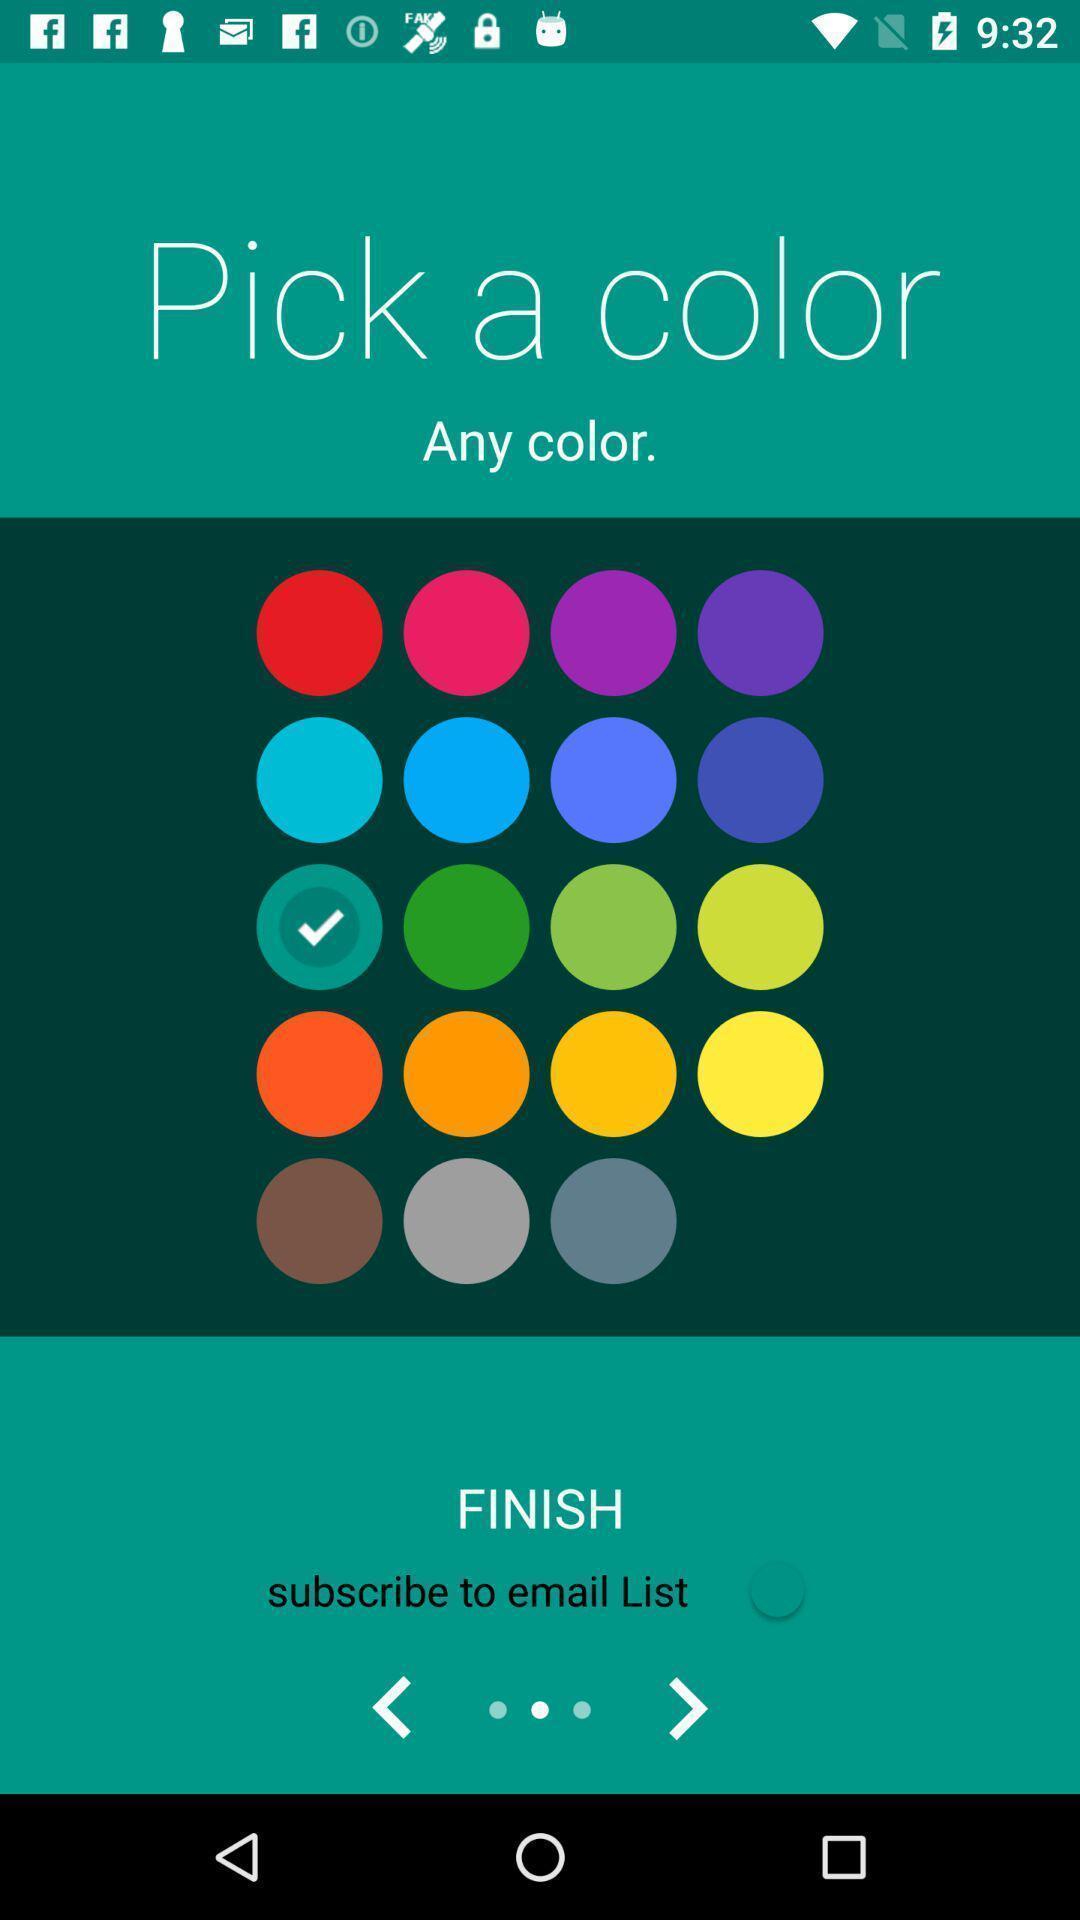Summarize the main components in this picture. Page requesting to pick a colour. 